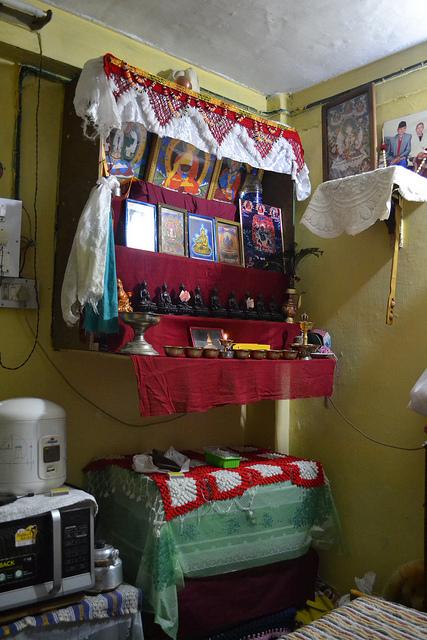Are family pictures on the wall?
Concise answer only. Yes. What color is the wall?
Answer briefly. Yellow. What pastel color is the long cloth on top of the table?
Answer briefly. Green. 